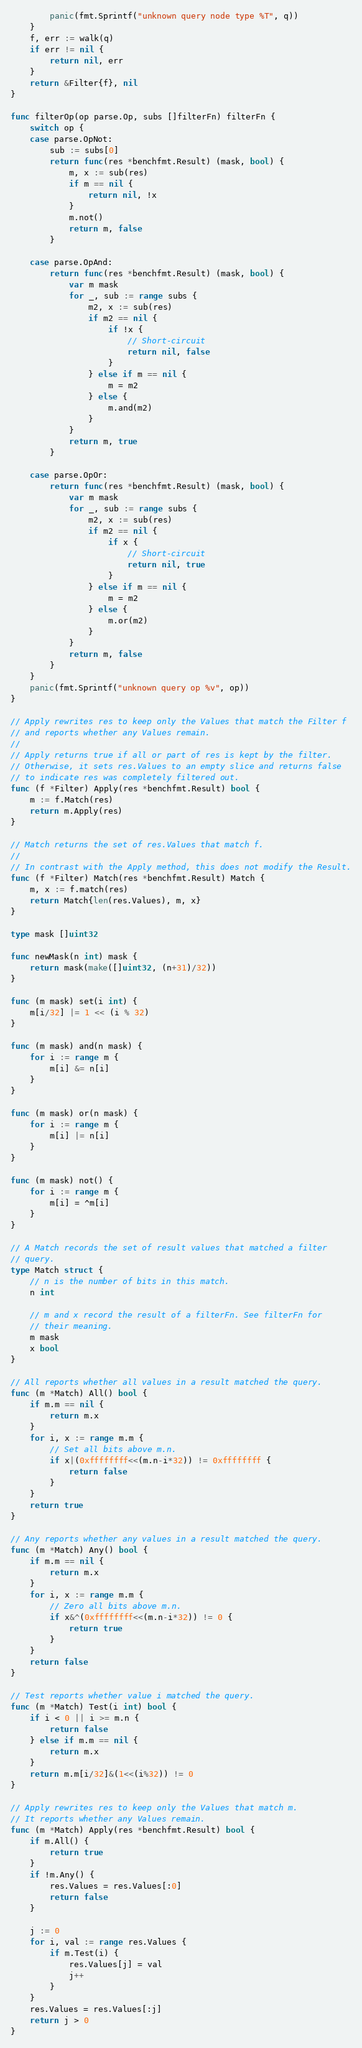Convert code to text. <code><loc_0><loc_0><loc_500><loc_500><_Go_>		panic(fmt.Sprintf("unknown query node type %T", q))
	}
	f, err := walk(q)
	if err != nil {
		return nil, err
	}
	return &Filter{f}, nil
}

func filterOp(op parse.Op, subs []filterFn) filterFn {
	switch op {
	case parse.OpNot:
		sub := subs[0]
		return func(res *benchfmt.Result) (mask, bool) {
			m, x := sub(res)
			if m == nil {
				return nil, !x
			}
			m.not()
			return m, false
		}

	case parse.OpAnd:
		return func(res *benchfmt.Result) (mask, bool) {
			var m mask
			for _, sub := range subs {
				m2, x := sub(res)
				if m2 == nil {
					if !x {
						// Short-circuit
						return nil, false
					}
				} else if m == nil {
					m = m2
				} else {
					m.and(m2)
				}
			}
			return m, true
		}

	case parse.OpOr:
		return func(res *benchfmt.Result) (mask, bool) {
			var m mask
			for _, sub := range subs {
				m2, x := sub(res)
				if m2 == nil {
					if x {
						// Short-circuit
						return nil, true
					}
				} else if m == nil {
					m = m2
				} else {
					m.or(m2)
				}
			}
			return m, false
		}
	}
	panic(fmt.Sprintf("unknown query op %v", op))
}

// Apply rewrites res to keep only the Values that match the Filter f
// and reports whether any Values remain.
//
// Apply returns true if all or part of res is kept by the filter.
// Otherwise, it sets res.Values to an empty slice and returns false
// to indicate res was completely filtered out.
func (f *Filter) Apply(res *benchfmt.Result) bool {
	m := f.Match(res)
	return m.Apply(res)
}

// Match returns the set of res.Values that match f.
//
// In contrast with the Apply method, this does not modify the Result.
func (f *Filter) Match(res *benchfmt.Result) Match {
	m, x := f.match(res)
	return Match{len(res.Values), m, x}
}

type mask []uint32

func newMask(n int) mask {
	return mask(make([]uint32, (n+31)/32))
}

func (m mask) set(i int) {
	m[i/32] |= 1 << (i % 32)
}

func (m mask) and(n mask) {
	for i := range m {
		m[i] &= n[i]
	}
}

func (m mask) or(n mask) {
	for i := range m {
		m[i] |= n[i]
	}
}

func (m mask) not() {
	for i := range m {
		m[i] = ^m[i]
	}
}

// A Match records the set of result values that matched a filter
// query.
type Match struct {
	// n is the number of bits in this match.
	n int

	// m and x record the result of a filterFn. See filterFn for
	// their meaning.
	m mask
	x bool
}

// All reports whether all values in a result matched the query.
func (m *Match) All() bool {
	if m.m == nil {
		return m.x
	}
	for i, x := range m.m {
		// Set all bits above m.n.
		if x|(0xffffffff<<(m.n-i*32)) != 0xffffffff {
			return false
		}
	}
	return true
}

// Any reports whether any values in a result matched the query.
func (m *Match) Any() bool {
	if m.m == nil {
		return m.x
	}
	for i, x := range m.m {
		// Zero all bits above m.n.
		if x&^(0xffffffff<<(m.n-i*32)) != 0 {
			return true
		}
	}
	return false
}

// Test reports whether value i matched the query.
func (m *Match) Test(i int) bool {
	if i < 0 || i >= m.n {
		return false
	} else if m.m == nil {
		return m.x
	}
	return m.m[i/32]&(1<<(i%32)) != 0
}

// Apply rewrites res to keep only the Values that match m.
// It reports whether any Values remain.
func (m *Match) Apply(res *benchfmt.Result) bool {
	if m.All() {
		return true
	}
	if !m.Any() {
		res.Values = res.Values[:0]
		return false
	}

	j := 0
	for i, val := range res.Values {
		if m.Test(i) {
			res.Values[j] = val
			j++
		}
	}
	res.Values = res.Values[:j]
	return j > 0
}
</code> 